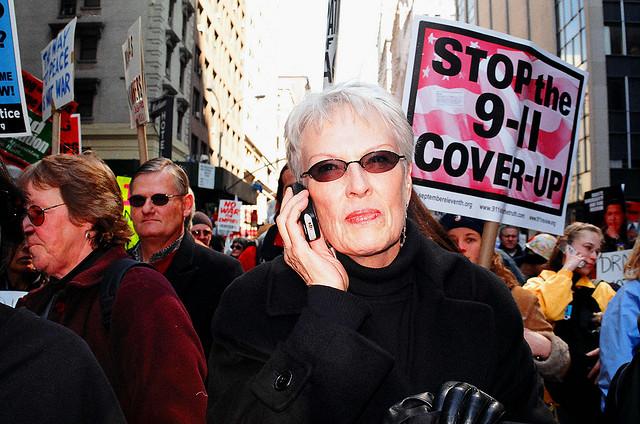What does the banner say?
Quick response, please. Stop 9-11 cover-up. Does the lady have a cell phone to her ear?
Keep it brief. Yes. What color is the woman's coat?
Short answer required. Black. What color is the lady's hair?
Concise answer only. Gray. Is the lady wearing sunglasses?
Answer briefly. Yes. 